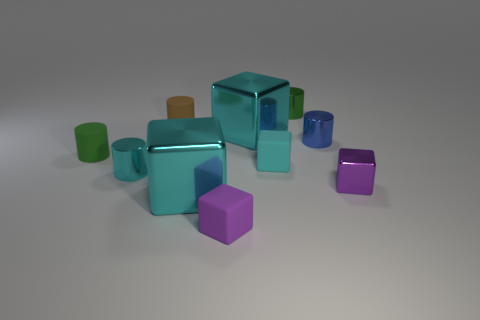There is a big cyan shiny thing behind the tiny cyan metallic thing; how many small blue metallic things are behind it?
Make the answer very short. 0. The cyan metal object that is behind the blue metallic cylinder has what shape?
Make the answer very short. Cube. The tiny green thing left of the tiny purple cube left of the tiny green thing that is right of the brown object is made of what material?
Keep it short and to the point. Rubber. How many other things are the same size as the purple metallic block?
Provide a succinct answer. 7. What material is the brown thing that is the same shape as the small green rubber object?
Provide a succinct answer. Rubber. What is the color of the small metal cube?
Ensure brevity in your answer.  Purple. What color is the tiny matte block in front of the shiny cube that is on the left side of the small purple rubber cube?
Keep it short and to the point. Purple. There is a small shiny block; is its color the same as the tiny rubber thing in front of the cyan shiny cylinder?
Offer a terse response. Yes. What number of metal cubes are behind the large cyan metallic object in front of the tiny blue cylinder that is left of the purple metal object?
Your answer should be compact. 2. Are there any tiny rubber things in front of the blue object?
Your answer should be very brief. Yes. 